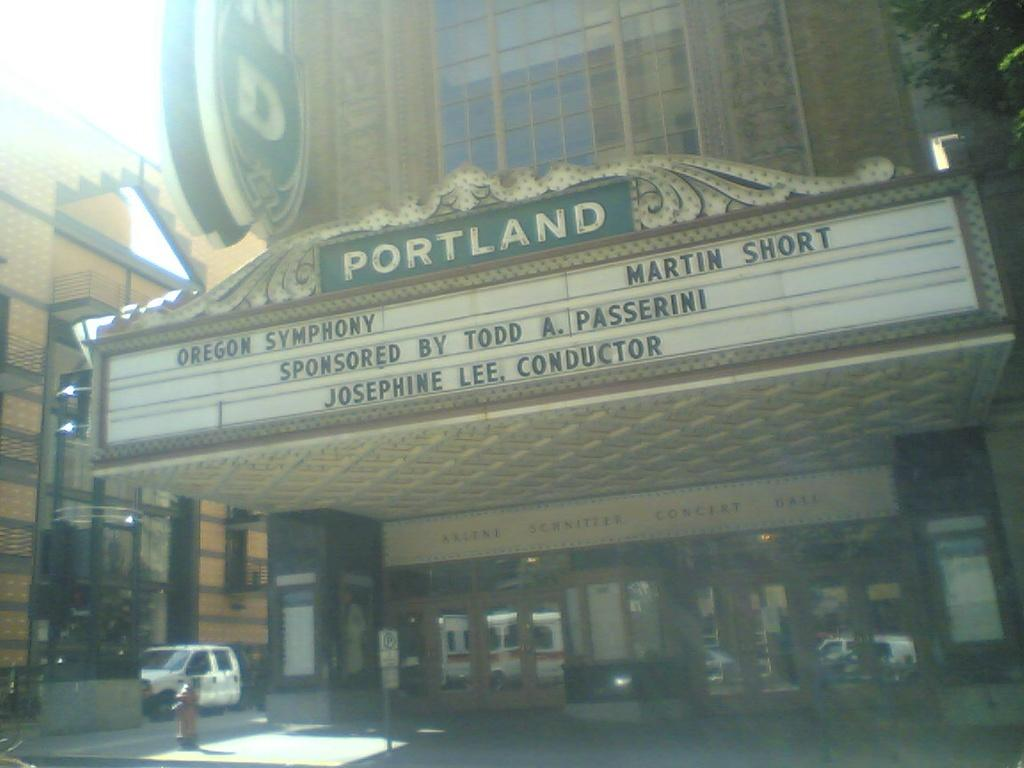What type of structure is present in the image? There is a building in the image. What can be seen on the building? There are boards on the building. What type of entrance is present on the building? There are glass doors on the building. What can be seen through the glass doors? Vehicles are visible through the glass doors. What are the vehicles doing in the image? The vehicles are moving on the road. What safety feature is present near the building? There is a water hydrant in the image. What type of natural scenery is visible in the background of the image? There are trees in the background of the image. What part of the natural environment is visible in the background of the image? The sky is visible in the background of the image. What type of crown is the achiever wearing in the image? There is no achiever or crown present in the image. 